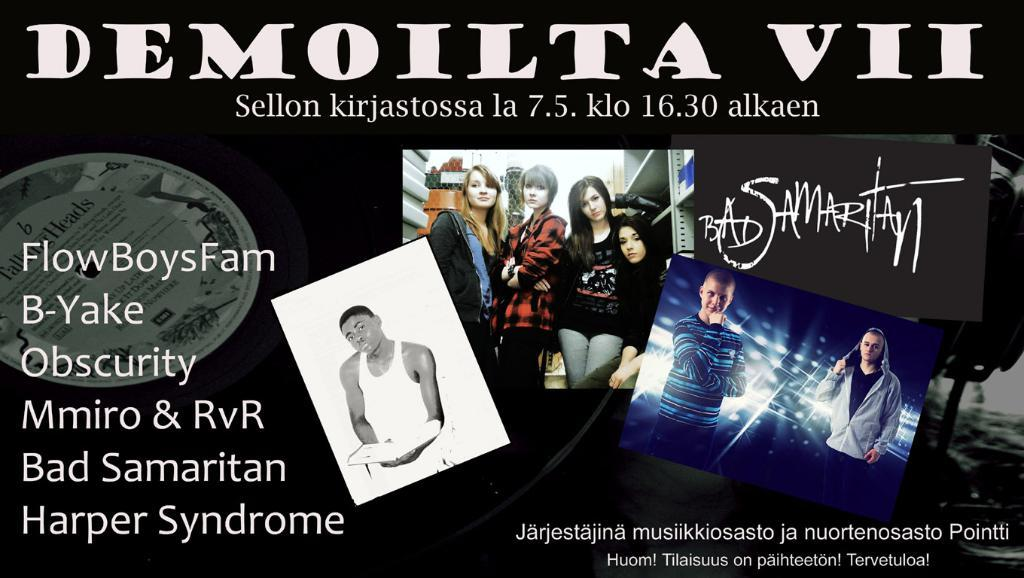<image>
Present a compact description of the photo's key features. A poster showing various performers for a concert. 